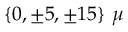<formula> <loc_0><loc_0><loc_500><loc_500>\{ 0 , \pm 5 , \pm 1 5 \} \mu</formula> 